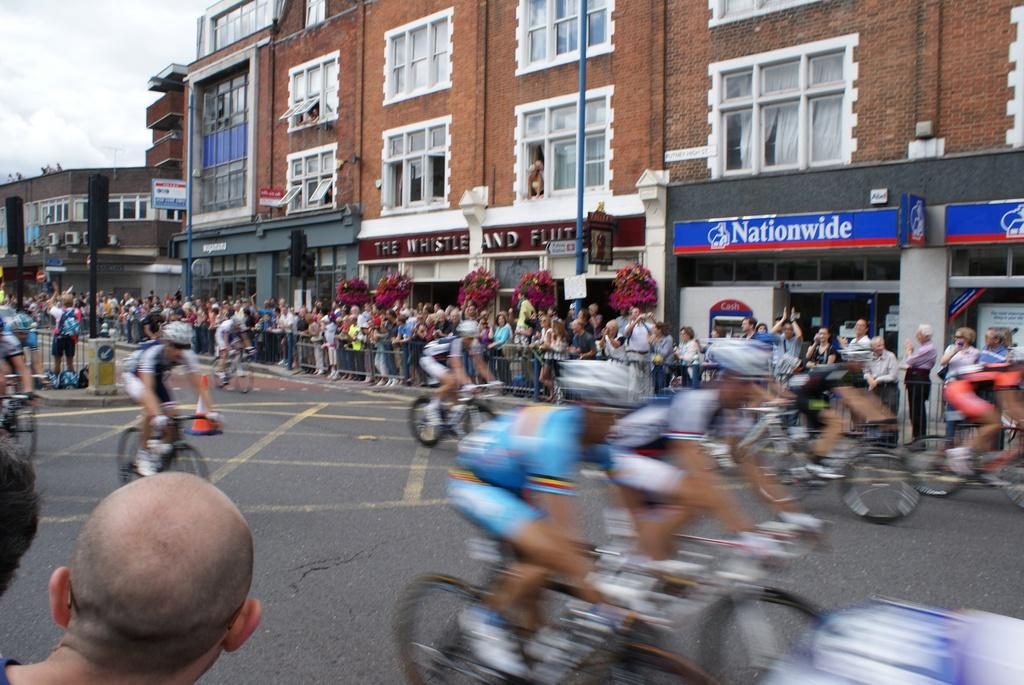Where is the image taken? The image is taken on a road. What are the people in the image doing? There are people riding bicycles on the road. What can be seen in the background of the image? There is a crowd, buildings, poles, and the sky visible in the background of the image. How many eyes can be seen on the bicycles in the image? There are no eyes present on the bicycles in the image; they are inanimate objects and do not have eyes. 